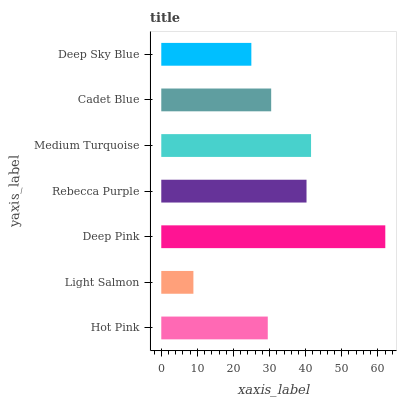Is Light Salmon the minimum?
Answer yes or no. Yes. Is Deep Pink the maximum?
Answer yes or no. Yes. Is Deep Pink the minimum?
Answer yes or no. No. Is Light Salmon the maximum?
Answer yes or no. No. Is Deep Pink greater than Light Salmon?
Answer yes or no. Yes. Is Light Salmon less than Deep Pink?
Answer yes or no. Yes. Is Light Salmon greater than Deep Pink?
Answer yes or no. No. Is Deep Pink less than Light Salmon?
Answer yes or no. No. Is Cadet Blue the high median?
Answer yes or no. Yes. Is Cadet Blue the low median?
Answer yes or no. Yes. Is Medium Turquoise the high median?
Answer yes or no. No. Is Hot Pink the low median?
Answer yes or no. No. 